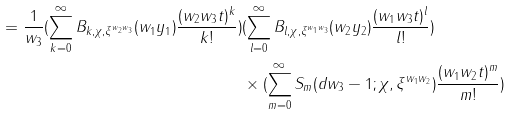<formula> <loc_0><loc_0><loc_500><loc_500>= \frac { 1 } { w _ { 3 } } ( \sum _ { k = 0 } ^ { \infty } B _ { k , \chi , \xi ^ { w _ { 2 } w _ { 3 } } } ( w _ { 1 } y _ { 1 } ) \frac { ( w _ { 2 } w _ { 3 } t ) ^ { k } } { k ! } ) & ( \sum _ { l = 0 } ^ { \infty } B _ { l , \chi , \xi ^ { w _ { 1 } w _ { 3 } } } ( w _ { 2 } y _ { 2 } ) \frac { ( w _ { 1 } w _ { 3 } t ) ^ { l } } { l ! } ) \\ & \times ( \sum _ { m = 0 } ^ { \infty } S _ { m } ( d w _ { 3 } - 1 ; \chi , \xi ^ { w _ { 1 } w _ { 2 } } ) \frac { ( w _ { 1 } w _ { 2 } t ) ^ { m } } { m ! } )</formula> 